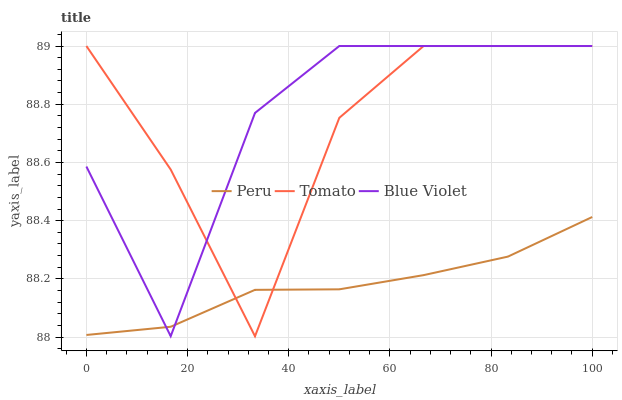Does Peru have the minimum area under the curve?
Answer yes or no. Yes. Does Blue Violet have the maximum area under the curve?
Answer yes or no. Yes. Does Blue Violet have the minimum area under the curve?
Answer yes or no. No. Does Peru have the maximum area under the curve?
Answer yes or no. No. Is Peru the smoothest?
Answer yes or no. Yes. Is Tomato the roughest?
Answer yes or no. Yes. Is Blue Violet the smoothest?
Answer yes or no. No. Is Blue Violet the roughest?
Answer yes or no. No. Does Tomato have the lowest value?
Answer yes or no. Yes. Does Blue Violet have the lowest value?
Answer yes or no. No. Does Blue Violet have the highest value?
Answer yes or no. Yes. Does Peru have the highest value?
Answer yes or no. No. Does Blue Violet intersect Tomato?
Answer yes or no. Yes. Is Blue Violet less than Tomato?
Answer yes or no. No. Is Blue Violet greater than Tomato?
Answer yes or no. No. 